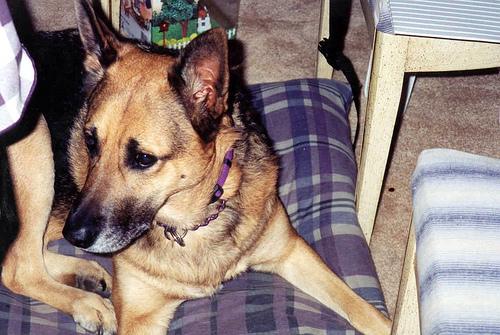Is the dog sitting or running?
Be succinct. Sitting. Is this a small dog?
Keep it brief. No. What breed of dog is this?
Quick response, please. German shepherd. 